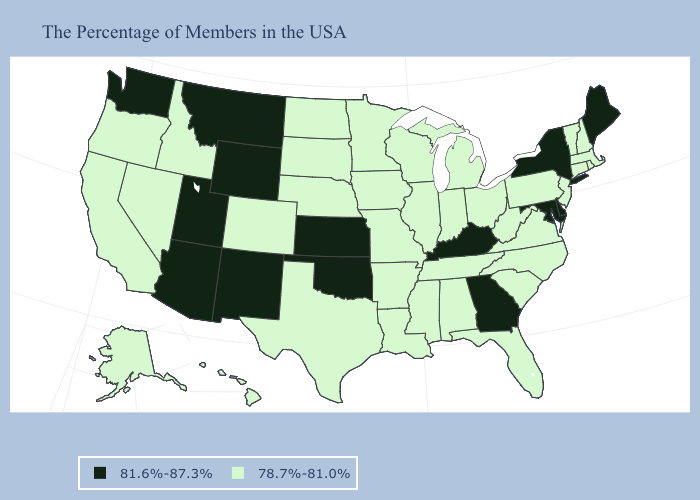Among the states that border Virginia , which have the lowest value?
Quick response, please. North Carolina, West Virginia, Tennessee. What is the value of California?
Give a very brief answer. 78.7%-81.0%. Does Montana have the lowest value in the USA?
Answer briefly. No. What is the lowest value in states that border Pennsylvania?
Short answer required. 78.7%-81.0%. Does Vermont have a lower value than Washington?
Concise answer only. Yes. What is the highest value in the South ?
Answer briefly. 81.6%-87.3%. Does the first symbol in the legend represent the smallest category?
Quick response, please. No. Among the states that border Maryland , which have the lowest value?
Answer briefly. Pennsylvania, Virginia, West Virginia. Name the states that have a value in the range 78.7%-81.0%?
Concise answer only. Massachusetts, Rhode Island, New Hampshire, Vermont, Connecticut, New Jersey, Pennsylvania, Virginia, North Carolina, South Carolina, West Virginia, Ohio, Florida, Michigan, Indiana, Alabama, Tennessee, Wisconsin, Illinois, Mississippi, Louisiana, Missouri, Arkansas, Minnesota, Iowa, Nebraska, Texas, South Dakota, North Dakota, Colorado, Idaho, Nevada, California, Oregon, Alaska, Hawaii. What is the value of Illinois?
Short answer required. 78.7%-81.0%. How many symbols are there in the legend?
Quick response, please. 2. Name the states that have a value in the range 81.6%-87.3%?
Be succinct. Maine, New York, Delaware, Maryland, Georgia, Kentucky, Kansas, Oklahoma, Wyoming, New Mexico, Utah, Montana, Arizona, Washington. What is the value of West Virginia?
Give a very brief answer. 78.7%-81.0%. What is the value of California?
Keep it brief. 78.7%-81.0%. Among the states that border Maine , which have the lowest value?
Be succinct. New Hampshire. 